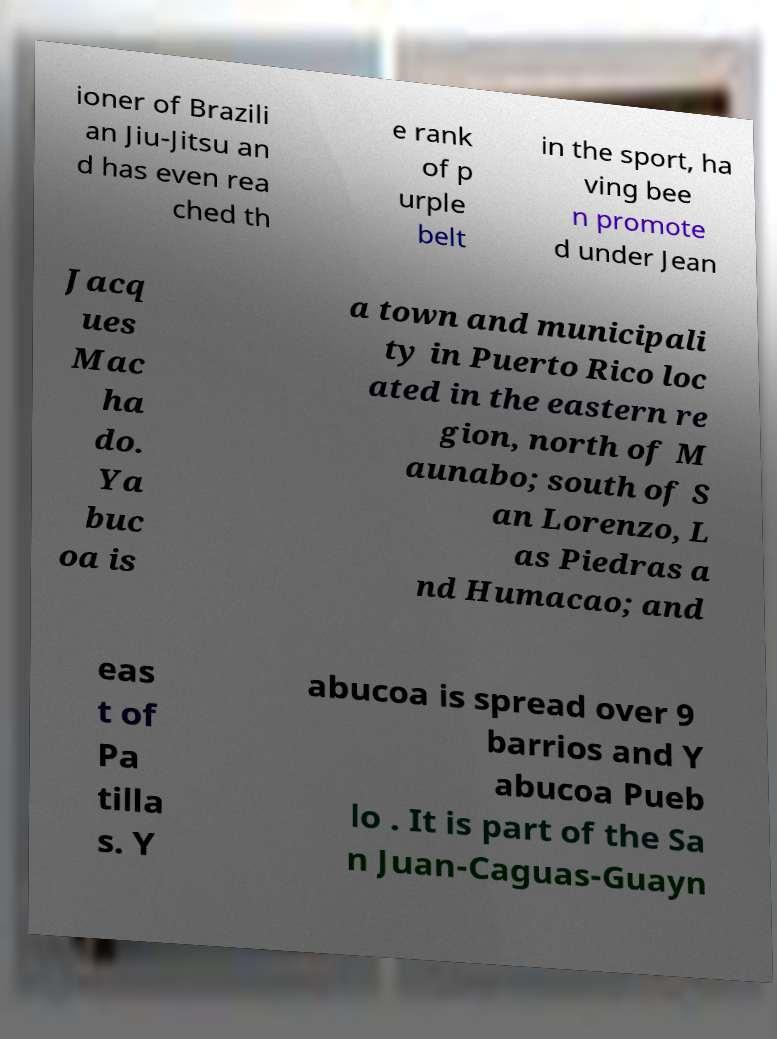Please read and relay the text visible in this image. What does it say? ioner of Brazili an Jiu-Jitsu an d has even rea ched th e rank of p urple belt in the sport, ha ving bee n promote d under Jean Jacq ues Mac ha do. Ya buc oa is a town and municipali ty in Puerto Rico loc ated in the eastern re gion, north of M aunabo; south of S an Lorenzo, L as Piedras a nd Humacao; and eas t of Pa tilla s. Y abucoa is spread over 9 barrios and Y abucoa Pueb lo . It is part of the Sa n Juan-Caguas-Guayn 